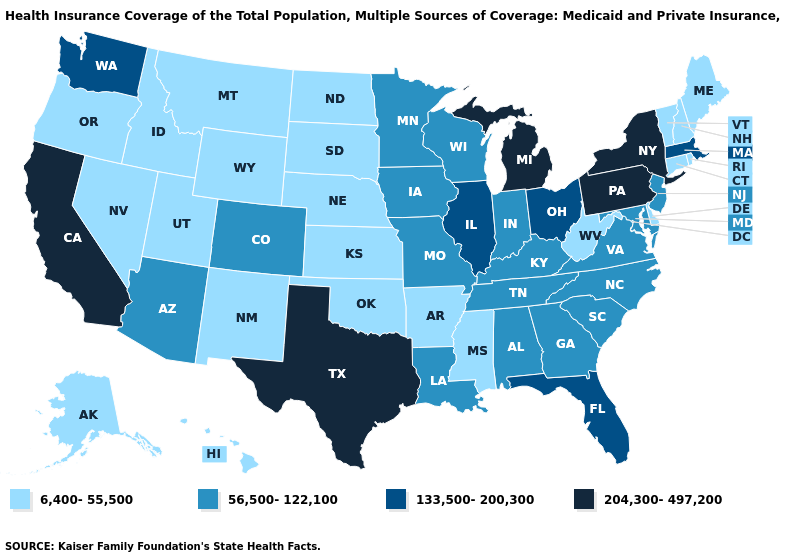What is the lowest value in states that border South Carolina?
Keep it brief. 56,500-122,100. Name the states that have a value in the range 6,400-55,500?
Answer briefly. Alaska, Arkansas, Connecticut, Delaware, Hawaii, Idaho, Kansas, Maine, Mississippi, Montana, Nebraska, Nevada, New Hampshire, New Mexico, North Dakota, Oklahoma, Oregon, Rhode Island, South Dakota, Utah, Vermont, West Virginia, Wyoming. Is the legend a continuous bar?
Be succinct. No. What is the lowest value in the USA?
Write a very short answer. 6,400-55,500. What is the lowest value in states that border Massachusetts?
Quick response, please. 6,400-55,500. Does West Virginia have the lowest value in the USA?
Concise answer only. Yes. What is the value of Nebraska?
Write a very short answer. 6,400-55,500. What is the value of Rhode Island?
Answer briefly. 6,400-55,500. Does Texas have the highest value in the USA?
Short answer required. Yes. Which states have the highest value in the USA?
Give a very brief answer. California, Michigan, New York, Pennsylvania, Texas. Does Montana have a lower value than Idaho?
Give a very brief answer. No. Name the states that have a value in the range 204,300-497,200?
Keep it brief. California, Michigan, New York, Pennsylvania, Texas. Does the map have missing data?
Be succinct. No. What is the value of Tennessee?
Concise answer only. 56,500-122,100. Among the states that border Iowa , does Wisconsin have the lowest value?
Give a very brief answer. No. 